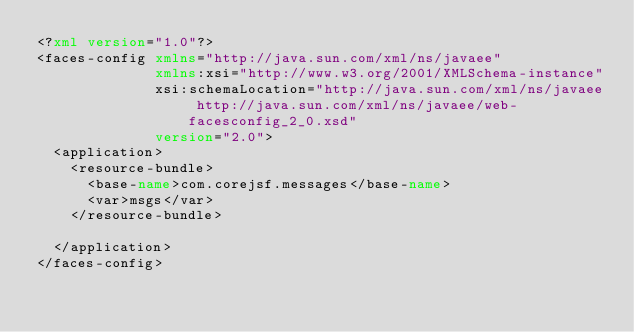Convert code to text. <code><loc_0><loc_0><loc_500><loc_500><_XML_><?xml version="1.0"?>
<faces-config xmlns="http://java.sun.com/xml/ns/javaee"
              xmlns:xsi="http://www.w3.org/2001/XMLSchema-instance"
              xsi:schemaLocation="http://java.sun.com/xml/ns/javaee http://java.sun.com/xml/ns/javaee/web-facesconfig_2_0.xsd"
              version="2.0">
  <application>
    <resource-bundle>
      <base-name>com.corejsf.messages</base-name>
      <var>msgs</var>
    </resource-bundle>
    
  </application>              
</faces-config></code> 